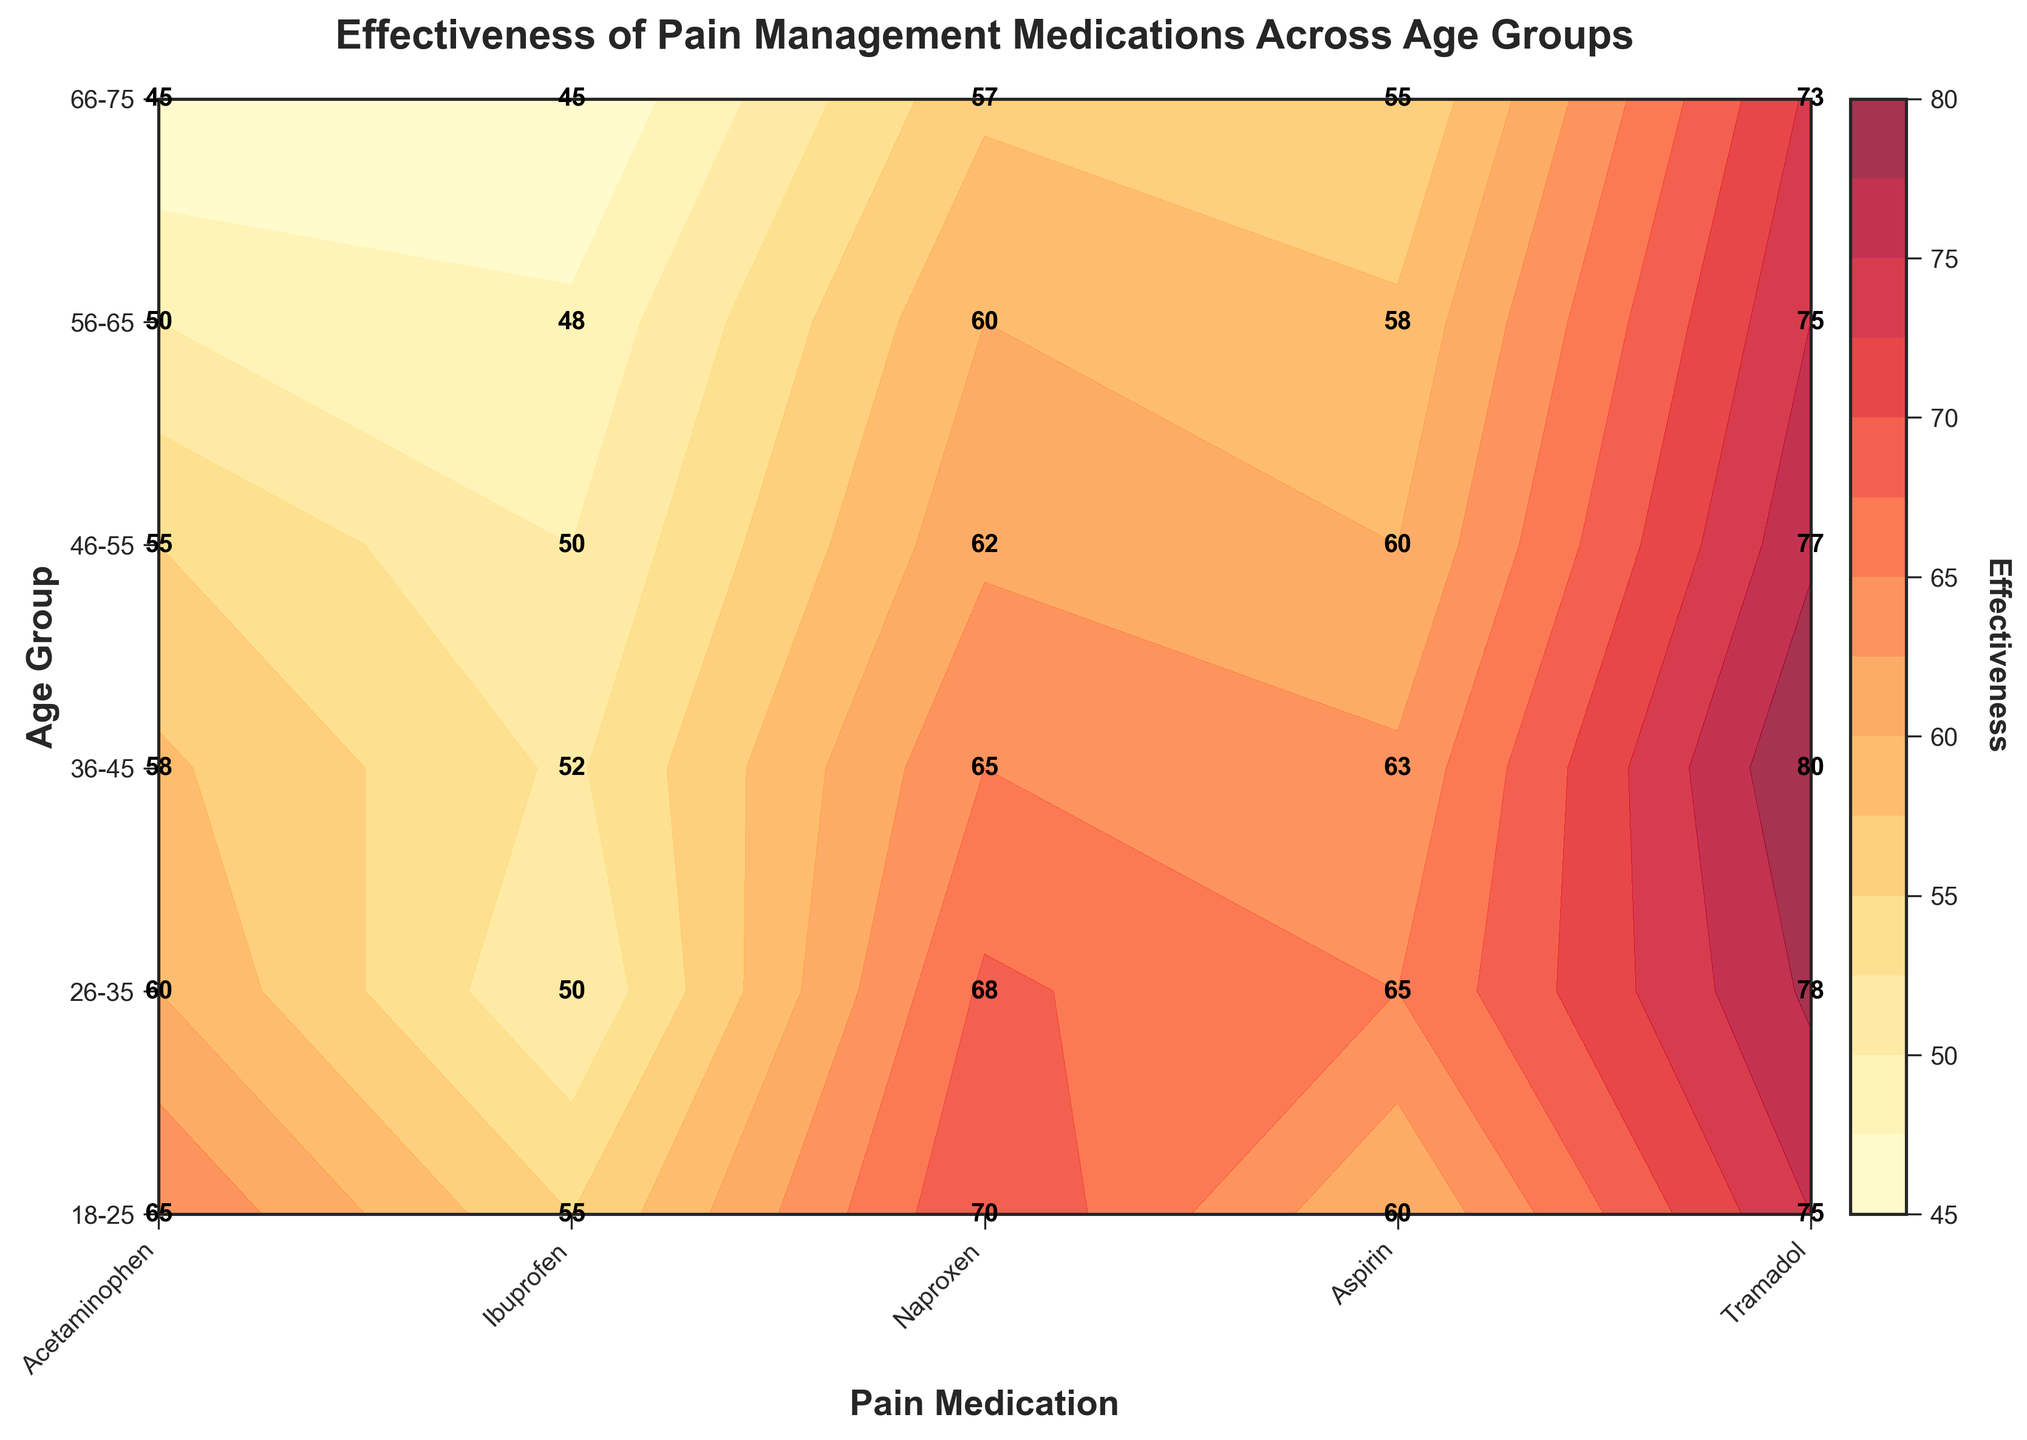What is the most effective pain medication for the age group 66-75? From the contour plot, the most effective pain medication for the age group 66-75 is Tramadol with an effectiveness of 73.
Answer: Tramadol Which age group finds Ibuprofen the least effective? By looking at the contour plot, Ibuprofen is the least effective with the effectiveness score of 57 for the age group 66-75.
Answer: 66-75 Which medication has the highest effectiveness score across all age groups? Tramadol consistently has the highest effectiveness scores across all age groups, with the highest being 80 for the 36-45 age group.
Answer: Tramadol Among the age groups 26-35 and 56-65, which group finds Acetaminophen more effective? For the age group 26-35, the effectiveness of Acetaminophen is 60, while for the age group 56-65, it is 50. Thus, the age group 26-35 finds Acetaminophen more effective.
Answer: 26-35 What is the difference in effectiveness of Tramadol between the age group 18-25 and 46-55? According to the contour plot, the effectiveness of Tramadol for the 18-25 age group is 75, and for the 46-55 age group, it is 77. The difference is 77 - 75 = 2.
Answer: 2 What’s the overall trend of effectiveness for Aspirin across different age groups? Observing the trends shown in the contour plot, the effectiveness of Aspirin decreases as the age groups increase: from 55 (18-25), 50 (26-35), 52 (36-45), 50 (46-55), 48 (56-65), to 45 (66-75).
Answer: Decreasing Which pain medication shows the least change in effectiveness across all age groups? By analyzing the contour plot, it can be observed that Aspirin shows the least change, fluctuating slightly around the 50-55 range across all age groups.
Answer: Aspirin How does the effectiveness of Naproxen and Ibuprofen compare for the age group 36-45? In the contour plot, for the 36-45 age group, Naproxen has an effectiveness of 63 while Ibuprofen has an effectiveness of 65, making Ibuprofen more effective by a small margin of 2.
Answer: Ibuprofen by 2 What is the median effectiveness of pain medications for the age group 56-65? For the age group 56-65, the effectiveness scores for Acetaminophen (50), Ibuprofen (60), Naproxen (58), Aspirin (48), and Tramadol (75) are considered. Arranging them in ascending order: 48, 50, 58, 60, 75. The median value is 58 (Naproxen).
Answer: 58 